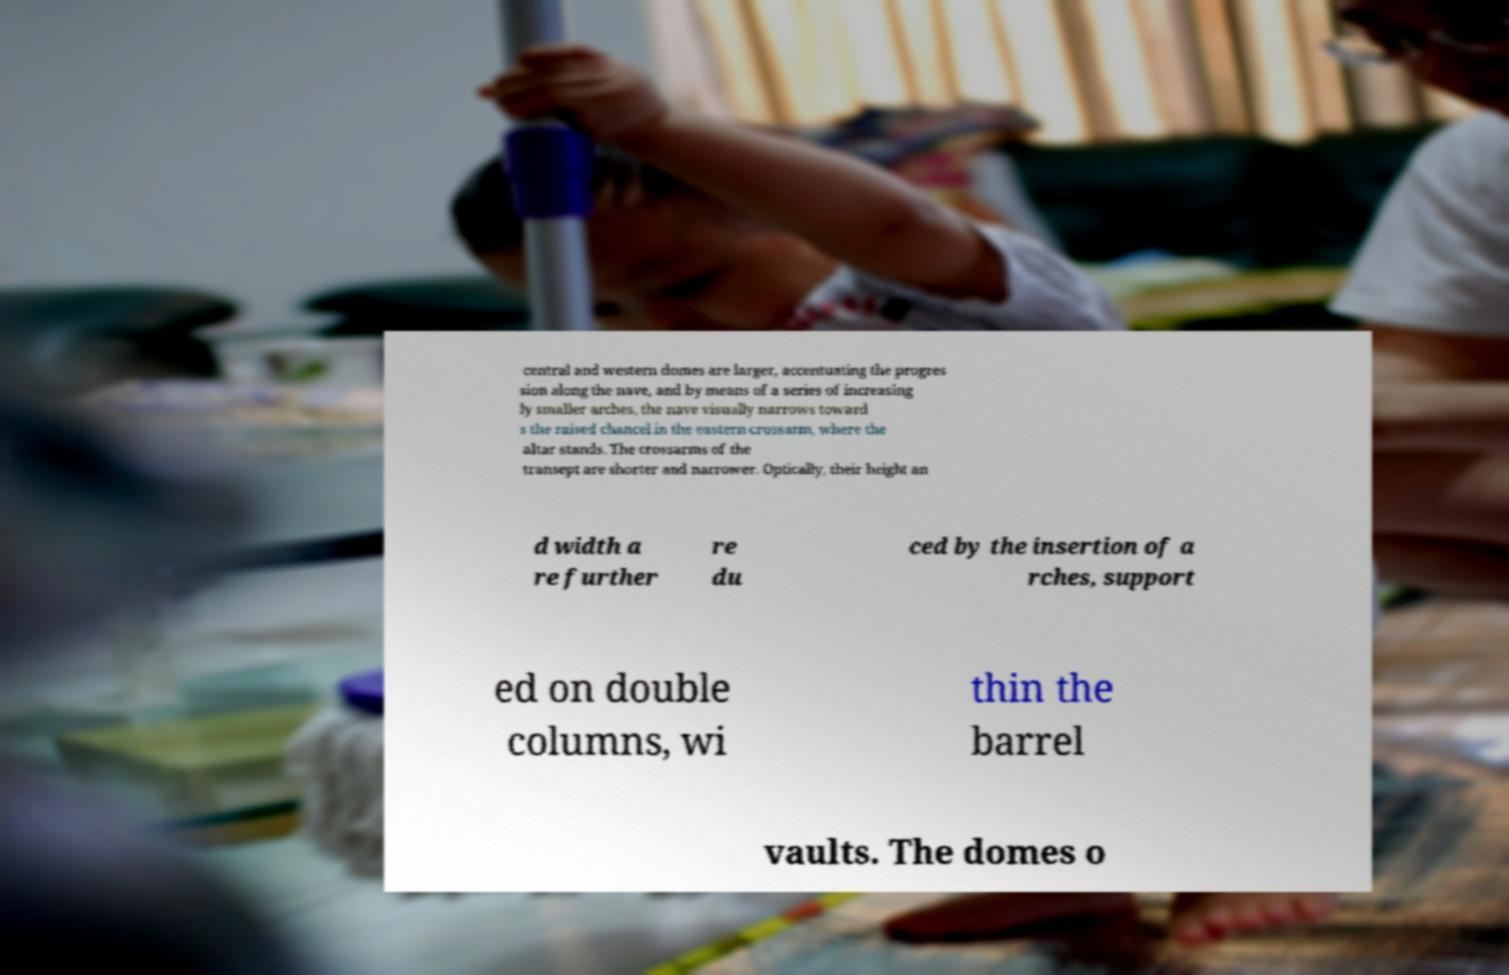Please identify and transcribe the text found in this image. central and western domes are larger, accentuating the progres sion along the nave, and by means of a series of increasing ly smaller arches, the nave visually narrows toward s the raised chancel in the eastern crossarm, where the altar stands. The crossarms of the transept are shorter and narrower. Optically, their height an d width a re further re du ced by the insertion of a rches, support ed on double columns, wi thin the barrel vaults. The domes o 